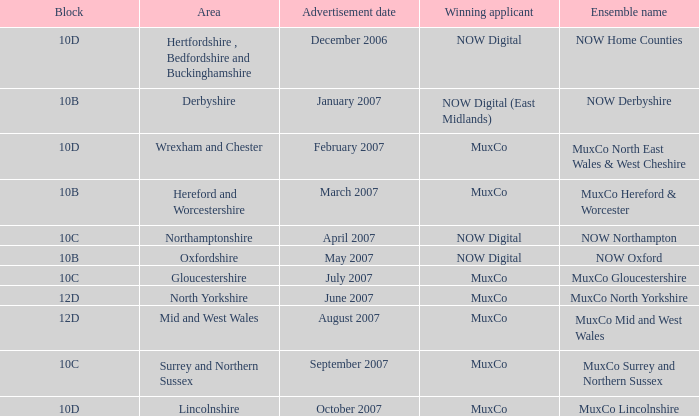What is Oxfordshire Area's Ensemble Name? NOW Oxford. 